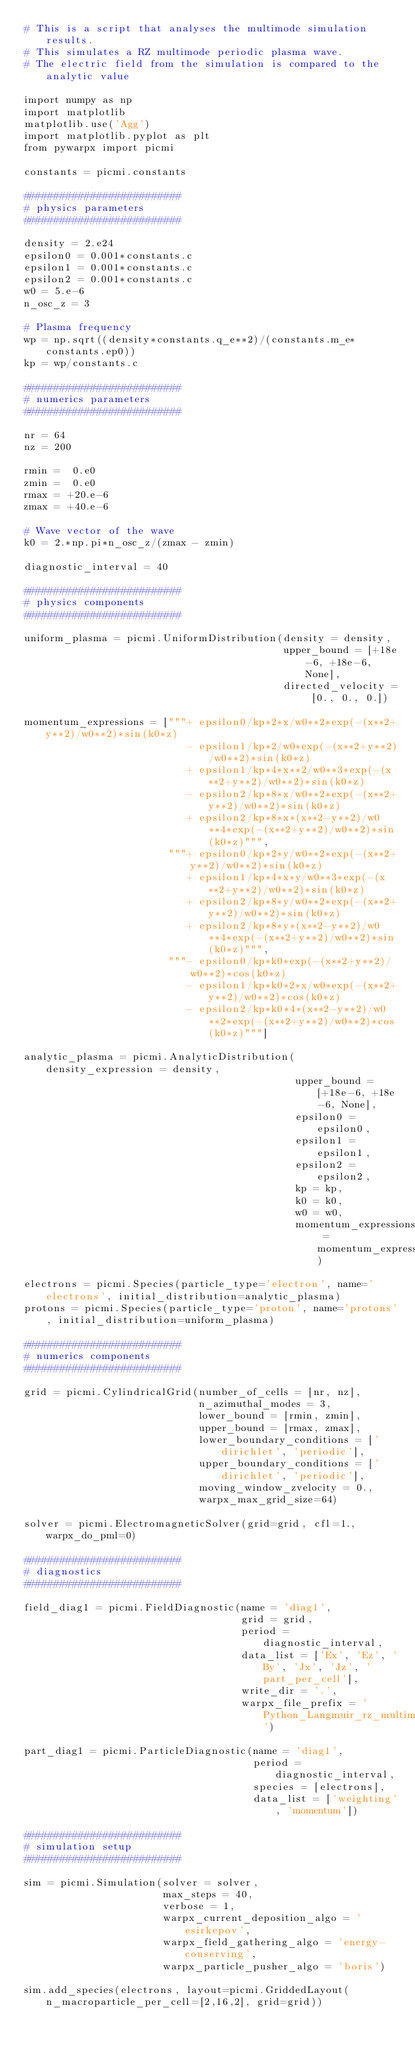Convert code to text. <code><loc_0><loc_0><loc_500><loc_500><_Python_># This is a script that analyses the multimode simulation results.
# This simulates a RZ multimode periodic plasma wave.
# The electric field from the simulation is compared to the analytic value

import numpy as np
import matplotlib
matplotlib.use('Agg')
import matplotlib.pyplot as plt
from pywarpx import picmi

constants = picmi.constants

##########################
# physics parameters
##########################

density = 2.e24
epsilon0 = 0.001*constants.c
epsilon1 = 0.001*constants.c
epsilon2 = 0.001*constants.c
w0 = 5.e-6
n_osc_z = 3

# Plasma frequency
wp = np.sqrt((density*constants.q_e**2)/(constants.m_e*constants.ep0))
kp = wp/constants.c

##########################
# numerics parameters
##########################

nr = 64
nz = 200

rmin =  0.e0
zmin =  0.e0
rmax = +20.e-6
zmax = +40.e-6

# Wave vector of the wave
k0 = 2.*np.pi*n_osc_z/(zmax - zmin)

diagnostic_interval = 40

##########################
# physics components
##########################

uniform_plasma = picmi.UniformDistribution(density = density,
                                           upper_bound = [+18e-6, +18e-6, None],
                                           directed_velocity = [0., 0., 0.])

momentum_expressions = ["""+ epsilon0/kp*2*x/w0**2*exp(-(x**2+y**2)/w0**2)*sin(k0*z)
                           - epsilon1/kp*2/w0*exp(-(x**2+y**2)/w0**2)*sin(k0*z)
                           + epsilon1/kp*4*x**2/w0**3*exp(-(x**2+y**2)/w0**2)*sin(k0*z)
                           - epsilon2/kp*8*x/w0**2*exp(-(x**2+y**2)/w0**2)*sin(k0*z)
                           + epsilon2/kp*8*x*(x**2-y**2)/w0**4*exp(-(x**2+y**2)/w0**2)*sin(k0*z)""",
                        """+ epsilon0/kp*2*y/w0**2*exp(-(x**2+y**2)/w0**2)*sin(k0*z)
                           + epsilon1/kp*4*x*y/w0**3*exp(-(x**2+y**2)/w0**2)*sin(k0*z)
                           + epsilon2/kp*8*y/w0**2*exp(-(x**2+y**2)/w0**2)*sin(k0*z)
                           + epsilon2/kp*8*y*(x**2-y**2)/w0**4*exp(-(x**2+y**2)/w0**2)*sin(k0*z)""",
                        """- epsilon0/kp*k0*exp(-(x**2+y**2)/w0**2)*cos(k0*z)
                           - epsilon1/kp*k0*2*x/w0*exp(-(x**2+y**2)/w0**2)*cos(k0*z)
                           - epsilon2/kp*k0*4*(x**2-y**2)/w0**2*exp(-(x**2+y**2)/w0**2)*cos(k0*z)"""]

analytic_plasma = picmi.AnalyticDistribution(density_expression = density,
                                             upper_bound = [+18e-6, +18e-6, None],
                                             epsilon0 = epsilon0,
                                             epsilon1 = epsilon1,
                                             epsilon2 = epsilon2,
                                             kp = kp,
                                             k0 = k0,
                                             w0 = w0,
                                             momentum_expressions = momentum_expressions)

electrons = picmi.Species(particle_type='electron', name='electrons', initial_distribution=analytic_plasma)
protons = picmi.Species(particle_type='proton', name='protons', initial_distribution=uniform_plasma)

##########################
# numerics components
##########################

grid = picmi.CylindricalGrid(number_of_cells = [nr, nz],
                             n_azimuthal_modes = 3,
                             lower_bound = [rmin, zmin],
                             upper_bound = [rmax, zmax],
                             lower_boundary_conditions = ['dirichlet', 'periodic'],
                             upper_boundary_conditions = ['dirichlet', 'periodic'],
                             moving_window_zvelocity = 0.,
                             warpx_max_grid_size=64)

solver = picmi.ElectromagneticSolver(grid=grid, cfl=1., warpx_do_pml=0)

##########################
# diagnostics
##########################

field_diag1 = picmi.FieldDiagnostic(name = 'diag1',
                                    grid = grid,
                                    period = diagnostic_interval,
                                    data_list = ['Ex', 'Ez', 'By', 'Jx', 'Jz', 'part_per_cell'],
                                    write_dir = '.',
                                    warpx_file_prefix = 'Python_Langmuir_rz_multimode_plt')

part_diag1 = picmi.ParticleDiagnostic(name = 'diag1',
                                      period = diagnostic_interval,
                                      species = [electrons],
                                      data_list = ['weighting', 'momentum'])

##########################
# simulation setup
##########################

sim = picmi.Simulation(solver = solver,
                       max_steps = 40,
                       verbose = 1,
                       warpx_current_deposition_algo = 'esirkepov',
                       warpx_field_gathering_algo = 'energy-conserving',
                       warpx_particle_pusher_algo = 'boris')

sim.add_species(electrons, layout=picmi.GriddedLayout(n_macroparticle_per_cell=[2,16,2], grid=grid))</code> 